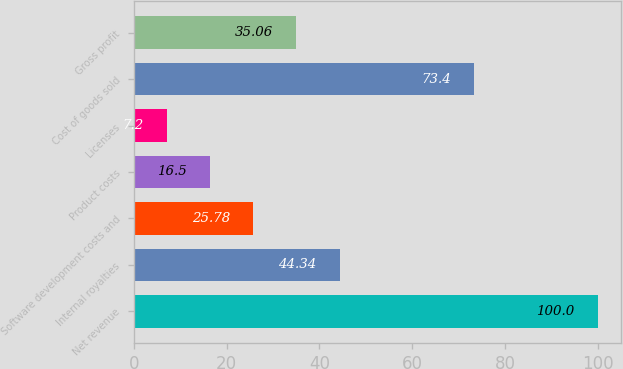Convert chart. <chart><loc_0><loc_0><loc_500><loc_500><bar_chart><fcel>Net revenue<fcel>Internal royalties<fcel>Software development costs and<fcel>Product costs<fcel>Licenses<fcel>Cost of goods sold<fcel>Gross profit<nl><fcel>100<fcel>44.34<fcel>25.78<fcel>16.5<fcel>7.2<fcel>73.4<fcel>35.06<nl></chart> 